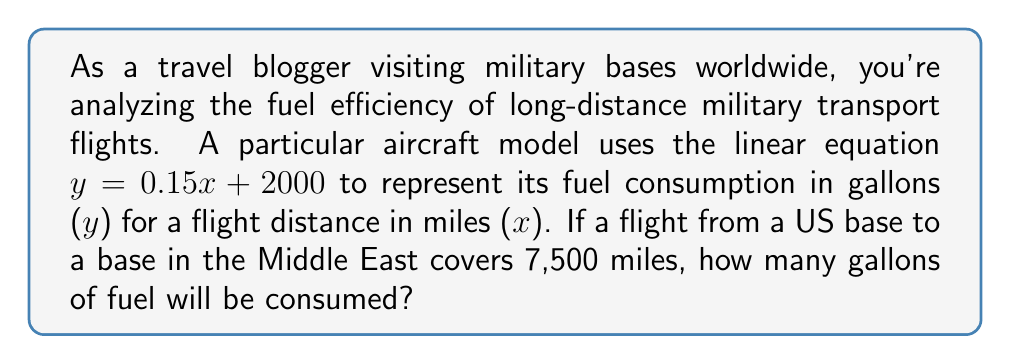Could you help me with this problem? To solve this problem, we'll use the given linear equation and substitute the known distance:

1) The linear equation is $y = 0.15x + 2000$, where:
   $y$ = fuel consumption in gallons
   $x$ = flight distance in miles

2) We know the flight distance is 7,500 miles, so we substitute $x = 7500$:

   $y = 0.15(7500) + 2000$

3) First, let's calculate the product inside the parentheses:
   $y = 0.15 * 7500 + 2000$
   $y = 1125 + 2000$

4) Now, we can add the results:
   $y = 3125$

Therefore, the aircraft will consume 3,125 gallons of fuel for the 7,500-mile flight.
Answer: 3,125 gallons 